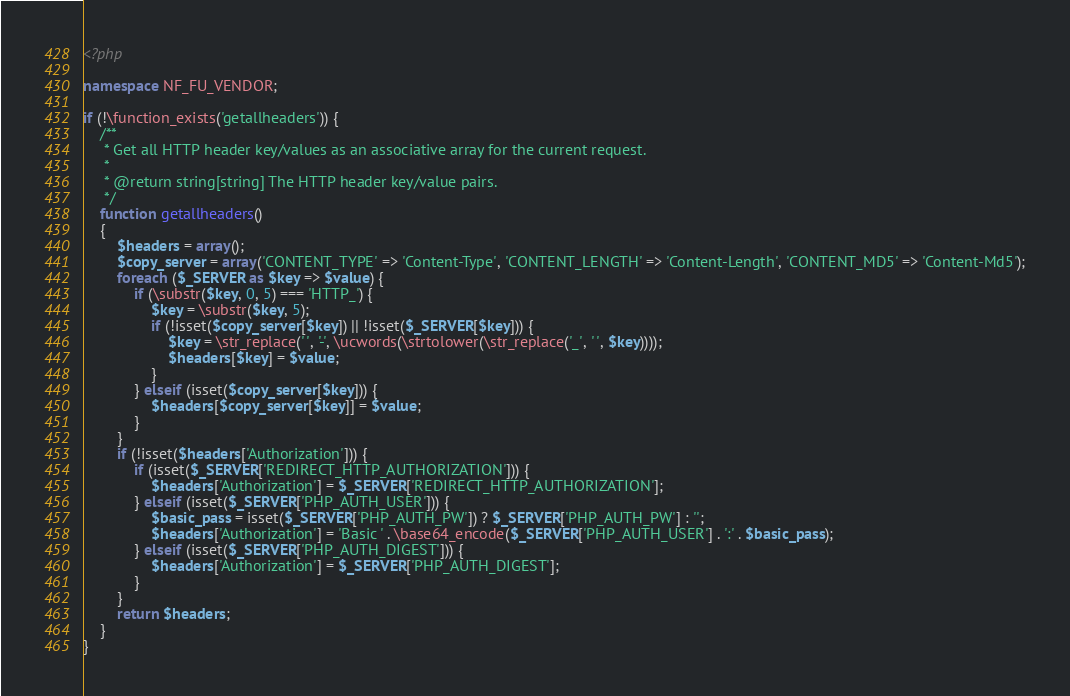<code> <loc_0><loc_0><loc_500><loc_500><_PHP_><?php

namespace NF_FU_VENDOR;

if (!\function_exists('getallheaders')) {
    /**
     * Get all HTTP header key/values as an associative array for the current request.
     *
     * @return string[string] The HTTP header key/value pairs.
     */
    function getallheaders()
    {
        $headers = array();
        $copy_server = array('CONTENT_TYPE' => 'Content-Type', 'CONTENT_LENGTH' => 'Content-Length', 'CONTENT_MD5' => 'Content-Md5');
        foreach ($_SERVER as $key => $value) {
            if (\substr($key, 0, 5) === 'HTTP_') {
                $key = \substr($key, 5);
                if (!isset($copy_server[$key]) || !isset($_SERVER[$key])) {
                    $key = \str_replace(' ', '-', \ucwords(\strtolower(\str_replace('_', ' ', $key))));
                    $headers[$key] = $value;
                }
            } elseif (isset($copy_server[$key])) {
                $headers[$copy_server[$key]] = $value;
            }
        }
        if (!isset($headers['Authorization'])) {
            if (isset($_SERVER['REDIRECT_HTTP_AUTHORIZATION'])) {
                $headers['Authorization'] = $_SERVER['REDIRECT_HTTP_AUTHORIZATION'];
            } elseif (isset($_SERVER['PHP_AUTH_USER'])) {
                $basic_pass = isset($_SERVER['PHP_AUTH_PW']) ? $_SERVER['PHP_AUTH_PW'] : '';
                $headers['Authorization'] = 'Basic ' . \base64_encode($_SERVER['PHP_AUTH_USER'] . ':' . $basic_pass);
            } elseif (isset($_SERVER['PHP_AUTH_DIGEST'])) {
                $headers['Authorization'] = $_SERVER['PHP_AUTH_DIGEST'];
            }
        }
        return $headers;
    }
}
</code> 